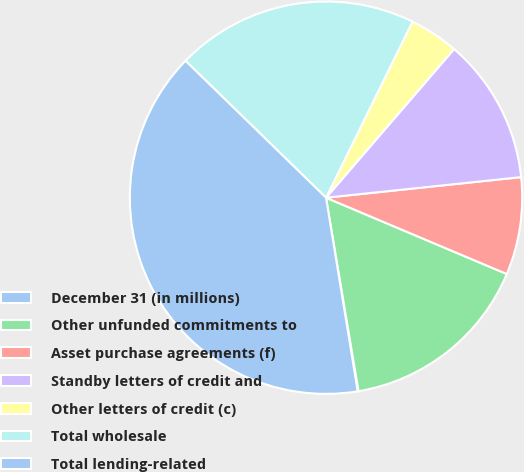<chart> <loc_0><loc_0><loc_500><loc_500><pie_chart><fcel>December 31 (in millions)<fcel>Other unfunded commitments to<fcel>Asset purchase agreements (f)<fcel>Standby letters of credit and<fcel>Other letters of credit (c)<fcel>Total wholesale<fcel>Total lending-related<nl><fcel>0.07%<fcel>15.99%<fcel>8.03%<fcel>12.01%<fcel>4.05%<fcel>19.97%<fcel>39.87%<nl></chart> 